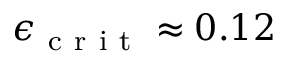<formula> <loc_0><loc_0><loc_500><loc_500>\epsilon _ { c r i t } \approx 0 . 1 2</formula> 